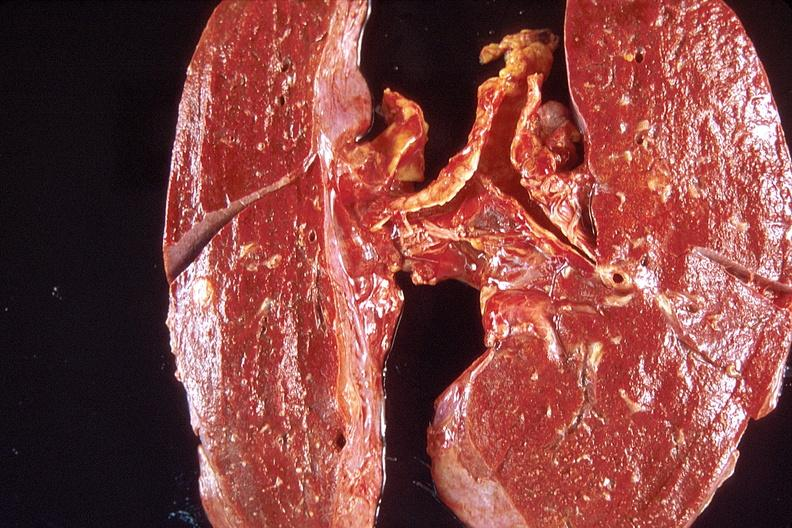where is this?
Answer the question using a single word or phrase. Lung 